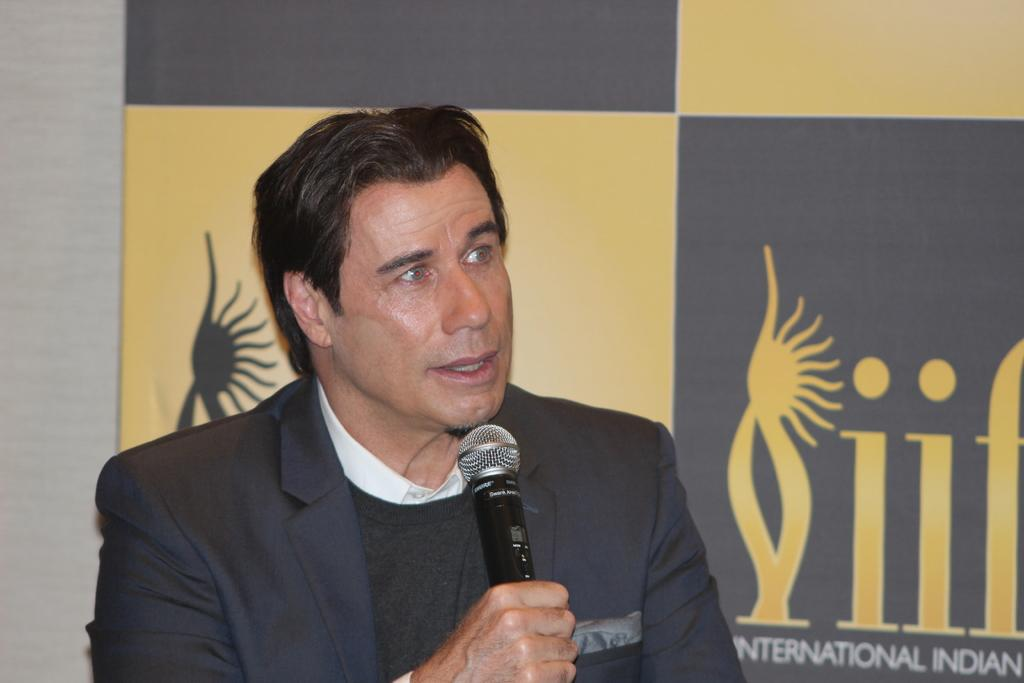Who is the main subject in the image? There is a man in the image. What is the man wearing? The man is wearing a suit. What is the man holding in his hand? The man is holding a mic in his hand. What type of ink is the man using to write on the paper in the image? There is no paper or ink present in the image; the man is holding a mic in his hand. 